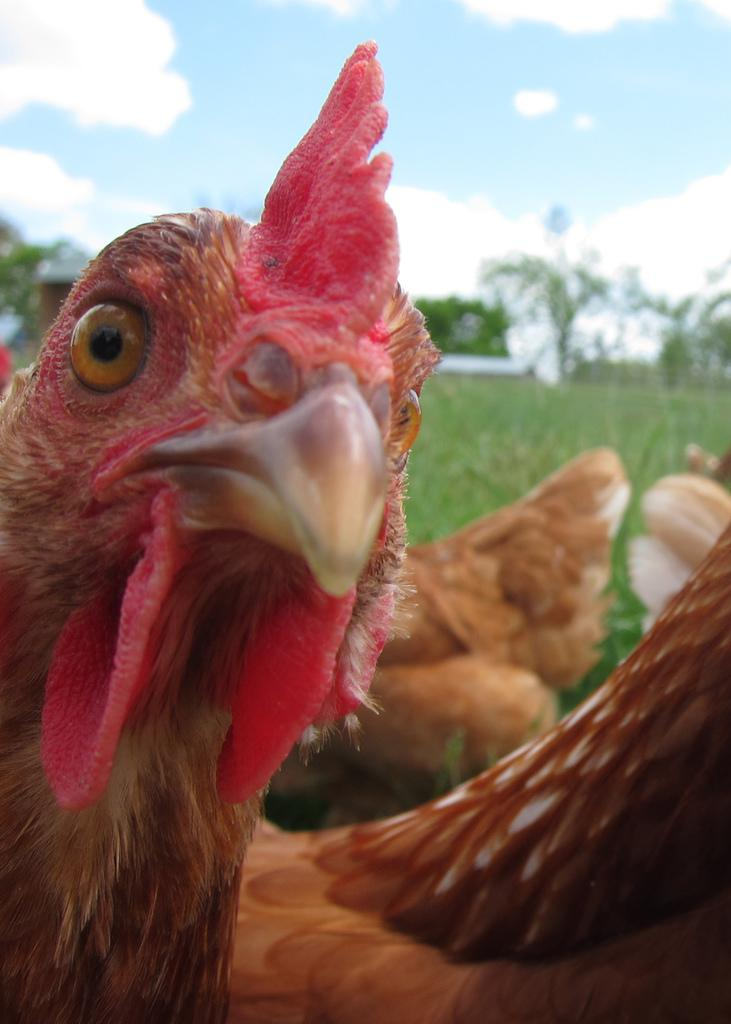What type of animals are in the image? There are hens in the image. What can be seen behind the hens? There are trees and grass behind the hens. What is visible at the top of the image? The sky is visible at the top of the image. What type of cap is the hen wearing in the image? There are no caps present in the image, as hens do not wear clothing. 